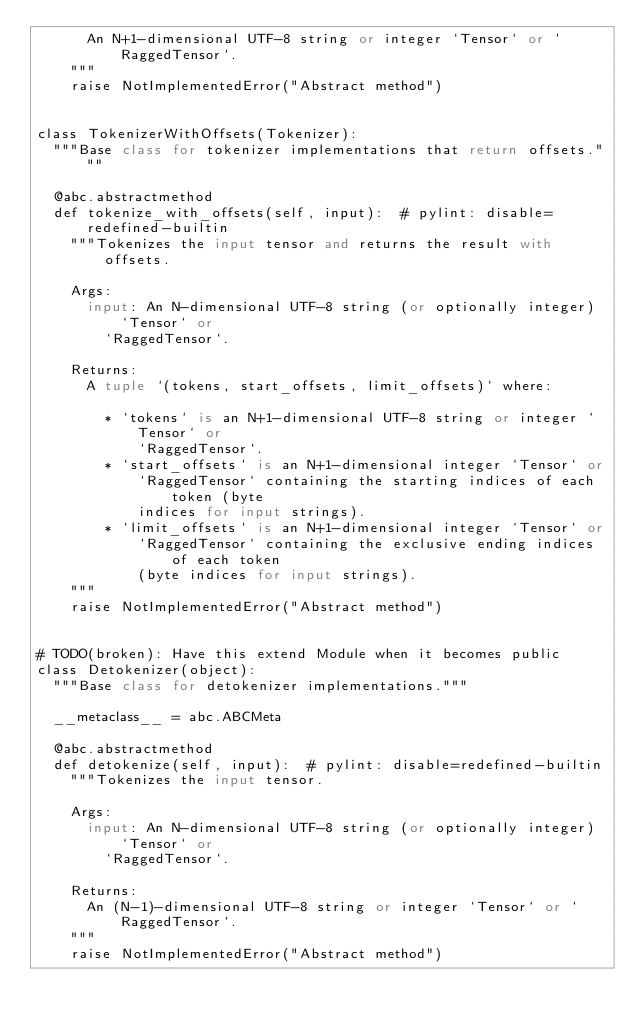Convert code to text. <code><loc_0><loc_0><loc_500><loc_500><_Python_>      An N+1-dimensional UTF-8 string or integer `Tensor` or `RaggedTensor`.
    """
    raise NotImplementedError("Abstract method")


class TokenizerWithOffsets(Tokenizer):
  """Base class for tokenizer implementations that return offsets."""

  @abc.abstractmethod
  def tokenize_with_offsets(self, input):  # pylint: disable=redefined-builtin
    """Tokenizes the input tensor and returns the result with offsets.

    Args:
      input: An N-dimensional UTF-8 string (or optionally integer) `Tensor` or
        `RaggedTensor`.

    Returns:
      A tuple `(tokens, start_offsets, limit_offsets)` where:

        * `tokens` is an N+1-dimensional UTF-8 string or integer `Tensor` or
            `RaggedTensor`.
        * `start_offsets` is an N+1-dimensional integer `Tensor` or
            `RaggedTensor` containing the starting indices of each token (byte
            indices for input strings).
        * `limit_offsets` is an N+1-dimensional integer `Tensor` or
            `RaggedTensor` containing the exclusive ending indices of each token
            (byte indices for input strings).
    """
    raise NotImplementedError("Abstract method")


# TODO(broken): Have this extend Module when it becomes public
class Detokenizer(object):
  """Base class for detokenizer implementations."""

  __metaclass__ = abc.ABCMeta

  @abc.abstractmethod
  def detokenize(self, input):  # pylint: disable=redefined-builtin
    """Tokenizes the input tensor.

    Args:
      input: An N-dimensional UTF-8 string (or optionally integer) `Tensor` or
        `RaggedTensor`.

    Returns:
      An (N-1)-dimensional UTF-8 string or integer `Tensor` or `RaggedTensor`.
    """
    raise NotImplementedError("Abstract method")
</code> 